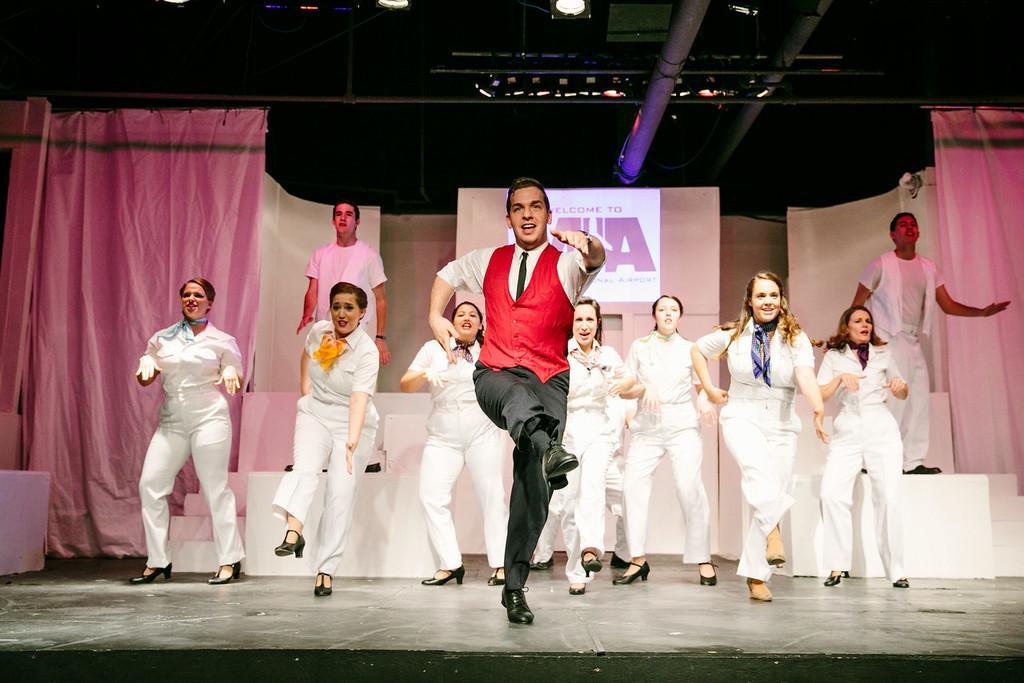In one or two sentences, can you explain what this image depicts? In this picture I can see a number of people dancing on the surface. I can see curtains on the both left and right sides. I can see the screen. I can see light arrangements on the roof. 